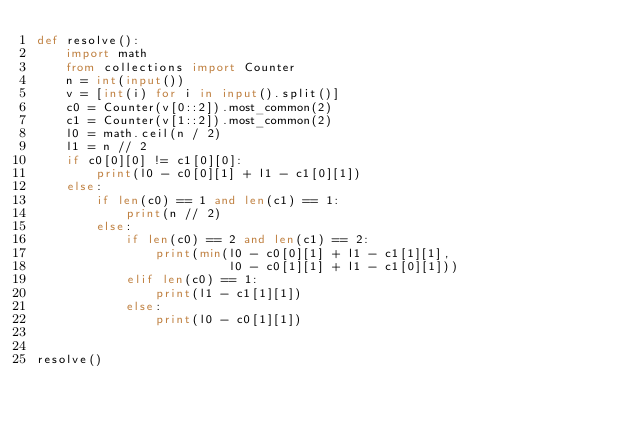Convert code to text. <code><loc_0><loc_0><loc_500><loc_500><_Python_>def resolve():
    import math
    from collections import Counter
    n = int(input())
    v = [int(i) for i in input().split()]
    c0 = Counter(v[0::2]).most_common(2)
    c1 = Counter(v[1::2]).most_common(2)
    l0 = math.ceil(n / 2)
    l1 = n // 2
    if c0[0][0] != c1[0][0]:
        print(l0 - c0[0][1] + l1 - c1[0][1])
    else:
        if len(c0) == 1 and len(c1) == 1:
            print(n // 2)
        else:
            if len(c0) == 2 and len(c1) == 2:
                print(min(l0 - c0[0][1] + l1 - c1[1][1],
                          l0 - c0[1][1] + l1 - c1[0][1]))
            elif len(c0) == 1:
                print(l1 - c1[1][1])
            else:
                print(l0 - c0[1][1])


resolve()
</code> 